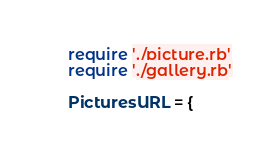<code> <loc_0><loc_0><loc_500><loc_500><_Ruby_>require './picture.rb'
require './gallery.rb'

PicturesURL = {</code> 